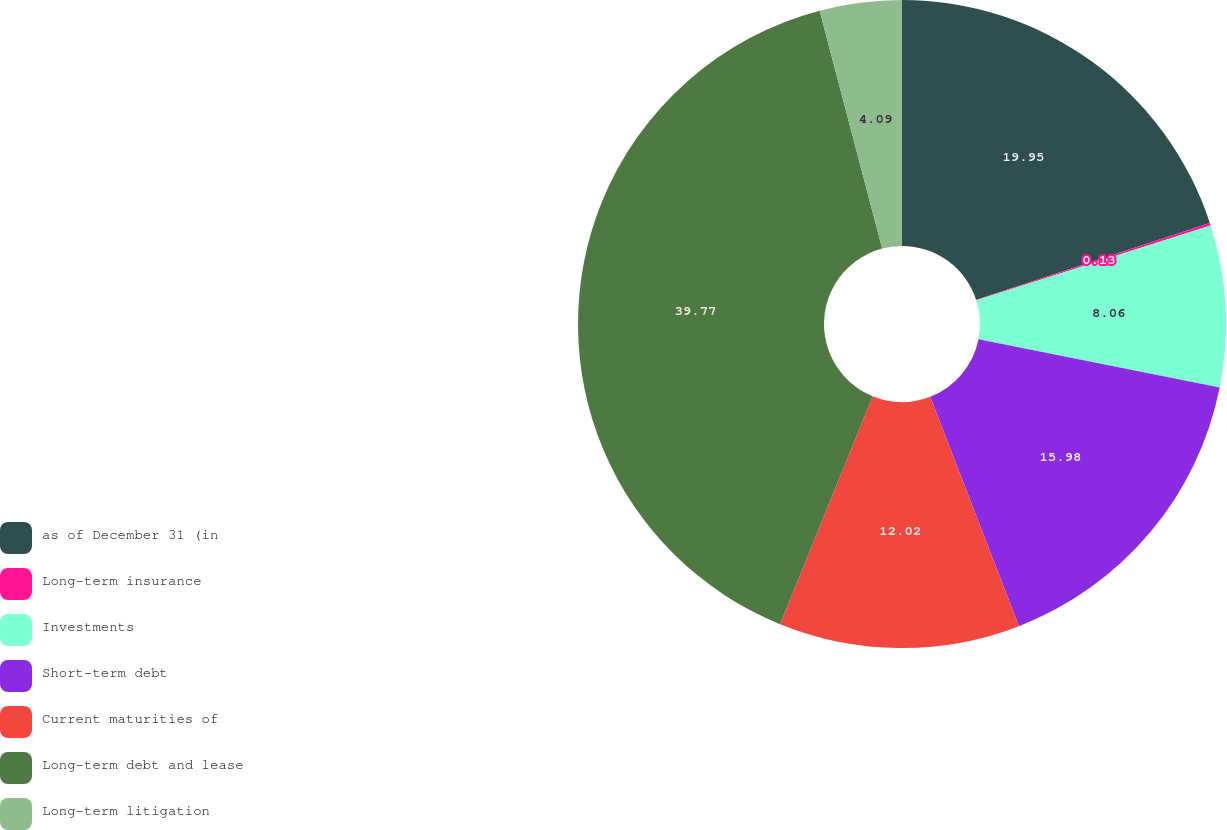Convert chart to OTSL. <chart><loc_0><loc_0><loc_500><loc_500><pie_chart><fcel>as of December 31 (in<fcel>Long-term insurance<fcel>Investments<fcel>Short-term debt<fcel>Current maturities of<fcel>Long-term debt and lease<fcel>Long-term litigation<nl><fcel>19.95%<fcel>0.13%<fcel>8.06%<fcel>15.98%<fcel>12.02%<fcel>39.77%<fcel>4.09%<nl></chart> 